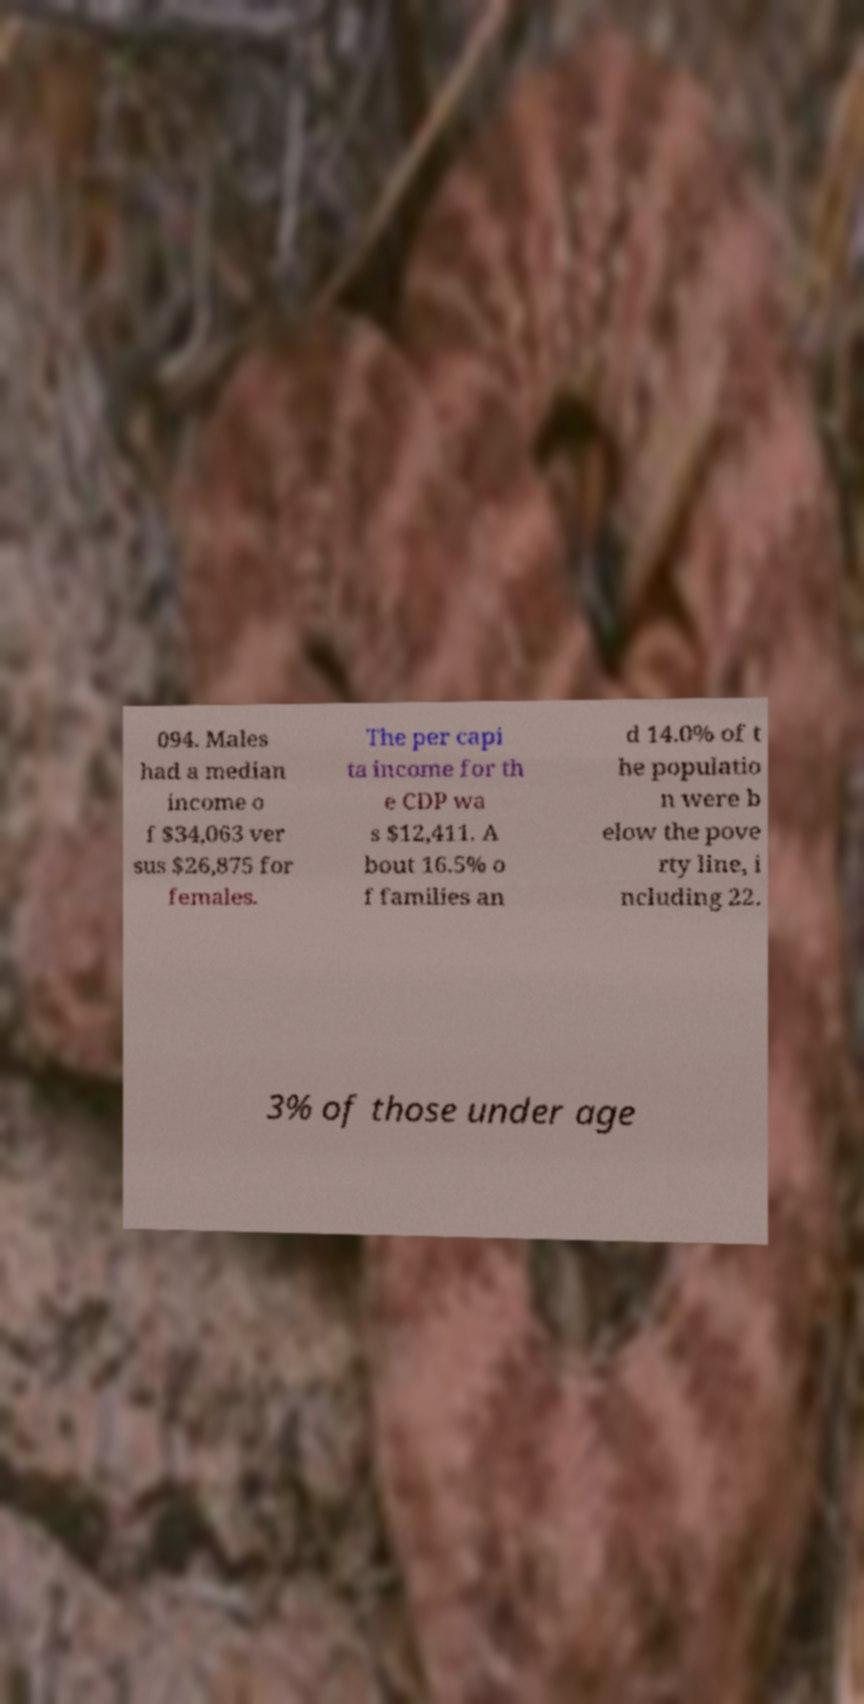Could you extract and type out the text from this image? 094. Males had a median income o f $34,063 ver sus $26,875 for females. The per capi ta income for th e CDP wa s $12,411. A bout 16.5% o f families an d 14.0% of t he populatio n were b elow the pove rty line, i ncluding 22. 3% of those under age 